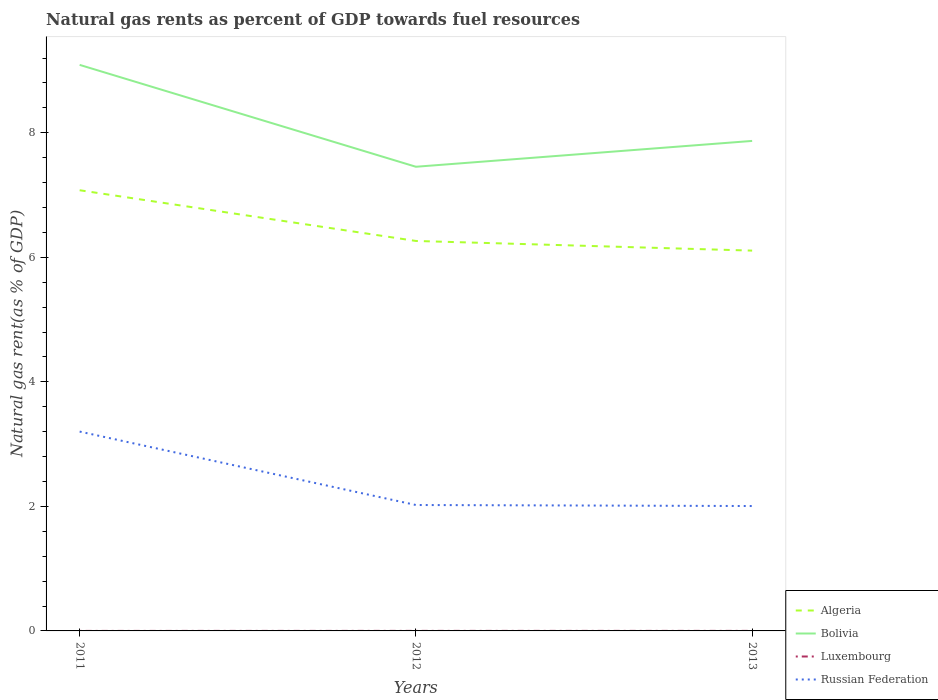Does the line corresponding to Bolivia intersect with the line corresponding to Luxembourg?
Offer a terse response. No. Across all years, what is the maximum natural gas rent in Russian Federation?
Your response must be concise. 2.01. What is the total natural gas rent in Bolivia in the graph?
Ensure brevity in your answer.  1.22. What is the difference between the highest and the second highest natural gas rent in Bolivia?
Your answer should be very brief. 1.64. What is the difference between the highest and the lowest natural gas rent in Algeria?
Offer a very short reply. 1. How many lines are there?
Provide a succinct answer. 4. How many years are there in the graph?
Keep it short and to the point. 3. Does the graph contain grids?
Your response must be concise. No. Where does the legend appear in the graph?
Ensure brevity in your answer.  Bottom right. What is the title of the graph?
Your answer should be compact. Natural gas rents as percent of GDP towards fuel resources. What is the label or title of the X-axis?
Provide a short and direct response. Years. What is the label or title of the Y-axis?
Offer a terse response. Natural gas rent(as % of GDP). What is the Natural gas rent(as % of GDP) of Algeria in 2011?
Offer a very short reply. 7.08. What is the Natural gas rent(as % of GDP) of Bolivia in 2011?
Ensure brevity in your answer.  9.09. What is the Natural gas rent(as % of GDP) of Luxembourg in 2011?
Keep it short and to the point. 0. What is the Natural gas rent(as % of GDP) of Russian Federation in 2011?
Provide a succinct answer. 3.2. What is the Natural gas rent(as % of GDP) of Algeria in 2012?
Offer a very short reply. 6.26. What is the Natural gas rent(as % of GDP) in Bolivia in 2012?
Your answer should be very brief. 7.45. What is the Natural gas rent(as % of GDP) in Luxembourg in 2012?
Ensure brevity in your answer.  0. What is the Natural gas rent(as % of GDP) in Russian Federation in 2012?
Your response must be concise. 2.02. What is the Natural gas rent(as % of GDP) of Algeria in 2013?
Give a very brief answer. 6.11. What is the Natural gas rent(as % of GDP) in Bolivia in 2013?
Your answer should be compact. 7.87. What is the Natural gas rent(as % of GDP) in Luxembourg in 2013?
Your answer should be compact. 0. What is the Natural gas rent(as % of GDP) in Russian Federation in 2013?
Provide a short and direct response. 2.01. Across all years, what is the maximum Natural gas rent(as % of GDP) of Algeria?
Make the answer very short. 7.08. Across all years, what is the maximum Natural gas rent(as % of GDP) of Bolivia?
Your answer should be compact. 9.09. Across all years, what is the maximum Natural gas rent(as % of GDP) of Luxembourg?
Provide a succinct answer. 0. Across all years, what is the maximum Natural gas rent(as % of GDP) in Russian Federation?
Offer a very short reply. 3.2. Across all years, what is the minimum Natural gas rent(as % of GDP) in Algeria?
Your answer should be compact. 6.11. Across all years, what is the minimum Natural gas rent(as % of GDP) in Bolivia?
Your answer should be compact. 7.45. Across all years, what is the minimum Natural gas rent(as % of GDP) of Luxembourg?
Ensure brevity in your answer.  0. Across all years, what is the minimum Natural gas rent(as % of GDP) in Russian Federation?
Your answer should be compact. 2.01. What is the total Natural gas rent(as % of GDP) in Algeria in the graph?
Make the answer very short. 19.45. What is the total Natural gas rent(as % of GDP) of Bolivia in the graph?
Offer a terse response. 24.41. What is the total Natural gas rent(as % of GDP) in Luxembourg in the graph?
Your answer should be compact. 0. What is the total Natural gas rent(as % of GDP) of Russian Federation in the graph?
Provide a short and direct response. 7.23. What is the difference between the Natural gas rent(as % of GDP) of Algeria in 2011 and that in 2012?
Give a very brief answer. 0.81. What is the difference between the Natural gas rent(as % of GDP) of Bolivia in 2011 and that in 2012?
Provide a short and direct response. 1.64. What is the difference between the Natural gas rent(as % of GDP) of Luxembourg in 2011 and that in 2012?
Give a very brief answer. -0. What is the difference between the Natural gas rent(as % of GDP) of Russian Federation in 2011 and that in 2012?
Your answer should be compact. 1.18. What is the difference between the Natural gas rent(as % of GDP) in Algeria in 2011 and that in 2013?
Your response must be concise. 0.97. What is the difference between the Natural gas rent(as % of GDP) in Bolivia in 2011 and that in 2013?
Offer a terse response. 1.22. What is the difference between the Natural gas rent(as % of GDP) in Luxembourg in 2011 and that in 2013?
Offer a very short reply. -0. What is the difference between the Natural gas rent(as % of GDP) of Russian Federation in 2011 and that in 2013?
Your answer should be very brief. 1.2. What is the difference between the Natural gas rent(as % of GDP) in Algeria in 2012 and that in 2013?
Offer a terse response. 0.15. What is the difference between the Natural gas rent(as % of GDP) in Bolivia in 2012 and that in 2013?
Your answer should be very brief. -0.41. What is the difference between the Natural gas rent(as % of GDP) in Luxembourg in 2012 and that in 2013?
Provide a short and direct response. 0. What is the difference between the Natural gas rent(as % of GDP) in Russian Federation in 2012 and that in 2013?
Offer a terse response. 0.02. What is the difference between the Natural gas rent(as % of GDP) in Algeria in 2011 and the Natural gas rent(as % of GDP) in Bolivia in 2012?
Ensure brevity in your answer.  -0.38. What is the difference between the Natural gas rent(as % of GDP) of Algeria in 2011 and the Natural gas rent(as % of GDP) of Luxembourg in 2012?
Provide a short and direct response. 7.08. What is the difference between the Natural gas rent(as % of GDP) in Algeria in 2011 and the Natural gas rent(as % of GDP) in Russian Federation in 2012?
Give a very brief answer. 5.06. What is the difference between the Natural gas rent(as % of GDP) of Bolivia in 2011 and the Natural gas rent(as % of GDP) of Luxembourg in 2012?
Your response must be concise. 9.09. What is the difference between the Natural gas rent(as % of GDP) of Bolivia in 2011 and the Natural gas rent(as % of GDP) of Russian Federation in 2012?
Provide a succinct answer. 7.07. What is the difference between the Natural gas rent(as % of GDP) of Luxembourg in 2011 and the Natural gas rent(as % of GDP) of Russian Federation in 2012?
Provide a succinct answer. -2.02. What is the difference between the Natural gas rent(as % of GDP) of Algeria in 2011 and the Natural gas rent(as % of GDP) of Bolivia in 2013?
Make the answer very short. -0.79. What is the difference between the Natural gas rent(as % of GDP) in Algeria in 2011 and the Natural gas rent(as % of GDP) in Luxembourg in 2013?
Your answer should be compact. 7.08. What is the difference between the Natural gas rent(as % of GDP) in Algeria in 2011 and the Natural gas rent(as % of GDP) in Russian Federation in 2013?
Your response must be concise. 5.07. What is the difference between the Natural gas rent(as % of GDP) of Bolivia in 2011 and the Natural gas rent(as % of GDP) of Luxembourg in 2013?
Provide a succinct answer. 9.09. What is the difference between the Natural gas rent(as % of GDP) in Bolivia in 2011 and the Natural gas rent(as % of GDP) in Russian Federation in 2013?
Ensure brevity in your answer.  7.08. What is the difference between the Natural gas rent(as % of GDP) in Luxembourg in 2011 and the Natural gas rent(as % of GDP) in Russian Federation in 2013?
Give a very brief answer. -2.01. What is the difference between the Natural gas rent(as % of GDP) in Algeria in 2012 and the Natural gas rent(as % of GDP) in Bolivia in 2013?
Your response must be concise. -1.61. What is the difference between the Natural gas rent(as % of GDP) of Algeria in 2012 and the Natural gas rent(as % of GDP) of Luxembourg in 2013?
Make the answer very short. 6.26. What is the difference between the Natural gas rent(as % of GDP) of Algeria in 2012 and the Natural gas rent(as % of GDP) of Russian Federation in 2013?
Your response must be concise. 4.26. What is the difference between the Natural gas rent(as % of GDP) in Bolivia in 2012 and the Natural gas rent(as % of GDP) in Luxembourg in 2013?
Offer a very short reply. 7.45. What is the difference between the Natural gas rent(as % of GDP) in Bolivia in 2012 and the Natural gas rent(as % of GDP) in Russian Federation in 2013?
Provide a short and direct response. 5.45. What is the difference between the Natural gas rent(as % of GDP) of Luxembourg in 2012 and the Natural gas rent(as % of GDP) of Russian Federation in 2013?
Ensure brevity in your answer.  -2. What is the average Natural gas rent(as % of GDP) of Algeria per year?
Your answer should be compact. 6.48. What is the average Natural gas rent(as % of GDP) in Bolivia per year?
Provide a short and direct response. 8.14. What is the average Natural gas rent(as % of GDP) in Russian Federation per year?
Keep it short and to the point. 2.41. In the year 2011, what is the difference between the Natural gas rent(as % of GDP) of Algeria and Natural gas rent(as % of GDP) of Bolivia?
Your response must be concise. -2.01. In the year 2011, what is the difference between the Natural gas rent(as % of GDP) in Algeria and Natural gas rent(as % of GDP) in Luxembourg?
Your response must be concise. 7.08. In the year 2011, what is the difference between the Natural gas rent(as % of GDP) in Algeria and Natural gas rent(as % of GDP) in Russian Federation?
Provide a succinct answer. 3.88. In the year 2011, what is the difference between the Natural gas rent(as % of GDP) in Bolivia and Natural gas rent(as % of GDP) in Luxembourg?
Ensure brevity in your answer.  9.09. In the year 2011, what is the difference between the Natural gas rent(as % of GDP) of Bolivia and Natural gas rent(as % of GDP) of Russian Federation?
Your response must be concise. 5.89. In the year 2011, what is the difference between the Natural gas rent(as % of GDP) in Luxembourg and Natural gas rent(as % of GDP) in Russian Federation?
Your answer should be very brief. -3.2. In the year 2012, what is the difference between the Natural gas rent(as % of GDP) of Algeria and Natural gas rent(as % of GDP) of Bolivia?
Your response must be concise. -1.19. In the year 2012, what is the difference between the Natural gas rent(as % of GDP) of Algeria and Natural gas rent(as % of GDP) of Luxembourg?
Offer a terse response. 6.26. In the year 2012, what is the difference between the Natural gas rent(as % of GDP) of Algeria and Natural gas rent(as % of GDP) of Russian Federation?
Provide a succinct answer. 4.24. In the year 2012, what is the difference between the Natural gas rent(as % of GDP) of Bolivia and Natural gas rent(as % of GDP) of Luxembourg?
Offer a very short reply. 7.45. In the year 2012, what is the difference between the Natural gas rent(as % of GDP) in Bolivia and Natural gas rent(as % of GDP) in Russian Federation?
Make the answer very short. 5.43. In the year 2012, what is the difference between the Natural gas rent(as % of GDP) of Luxembourg and Natural gas rent(as % of GDP) of Russian Federation?
Your answer should be compact. -2.02. In the year 2013, what is the difference between the Natural gas rent(as % of GDP) of Algeria and Natural gas rent(as % of GDP) of Bolivia?
Offer a very short reply. -1.76. In the year 2013, what is the difference between the Natural gas rent(as % of GDP) of Algeria and Natural gas rent(as % of GDP) of Luxembourg?
Give a very brief answer. 6.11. In the year 2013, what is the difference between the Natural gas rent(as % of GDP) of Algeria and Natural gas rent(as % of GDP) of Russian Federation?
Your answer should be compact. 4.1. In the year 2013, what is the difference between the Natural gas rent(as % of GDP) of Bolivia and Natural gas rent(as % of GDP) of Luxembourg?
Make the answer very short. 7.87. In the year 2013, what is the difference between the Natural gas rent(as % of GDP) of Bolivia and Natural gas rent(as % of GDP) of Russian Federation?
Give a very brief answer. 5.86. In the year 2013, what is the difference between the Natural gas rent(as % of GDP) in Luxembourg and Natural gas rent(as % of GDP) in Russian Federation?
Offer a very short reply. -2. What is the ratio of the Natural gas rent(as % of GDP) in Algeria in 2011 to that in 2012?
Give a very brief answer. 1.13. What is the ratio of the Natural gas rent(as % of GDP) in Bolivia in 2011 to that in 2012?
Ensure brevity in your answer.  1.22. What is the ratio of the Natural gas rent(as % of GDP) in Luxembourg in 2011 to that in 2012?
Give a very brief answer. 0.3. What is the ratio of the Natural gas rent(as % of GDP) of Russian Federation in 2011 to that in 2012?
Make the answer very short. 1.58. What is the ratio of the Natural gas rent(as % of GDP) of Algeria in 2011 to that in 2013?
Keep it short and to the point. 1.16. What is the ratio of the Natural gas rent(as % of GDP) in Bolivia in 2011 to that in 2013?
Make the answer very short. 1.16. What is the ratio of the Natural gas rent(as % of GDP) in Luxembourg in 2011 to that in 2013?
Your answer should be compact. 0.31. What is the ratio of the Natural gas rent(as % of GDP) of Russian Federation in 2011 to that in 2013?
Give a very brief answer. 1.6. What is the ratio of the Natural gas rent(as % of GDP) in Algeria in 2012 to that in 2013?
Your answer should be very brief. 1.03. What is the ratio of the Natural gas rent(as % of GDP) in Bolivia in 2012 to that in 2013?
Offer a very short reply. 0.95. What is the ratio of the Natural gas rent(as % of GDP) of Luxembourg in 2012 to that in 2013?
Make the answer very short. 1.03. What is the ratio of the Natural gas rent(as % of GDP) in Russian Federation in 2012 to that in 2013?
Give a very brief answer. 1.01. What is the difference between the highest and the second highest Natural gas rent(as % of GDP) of Algeria?
Keep it short and to the point. 0.81. What is the difference between the highest and the second highest Natural gas rent(as % of GDP) of Bolivia?
Provide a short and direct response. 1.22. What is the difference between the highest and the second highest Natural gas rent(as % of GDP) of Russian Federation?
Offer a terse response. 1.18. What is the difference between the highest and the lowest Natural gas rent(as % of GDP) of Algeria?
Ensure brevity in your answer.  0.97. What is the difference between the highest and the lowest Natural gas rent(as % of GDP) in Bolivia?
Provide a succinct answer. 1.64. What is the difference between the highest and the lowest Natural gas rent(as % of GDP) of Luxembourg?
Offer a terse response. 0. What is the difference between the highest and the lowest Natural gas rent(as % of GDP) of Russian Federation?
Offer a terse response. 1.2. 